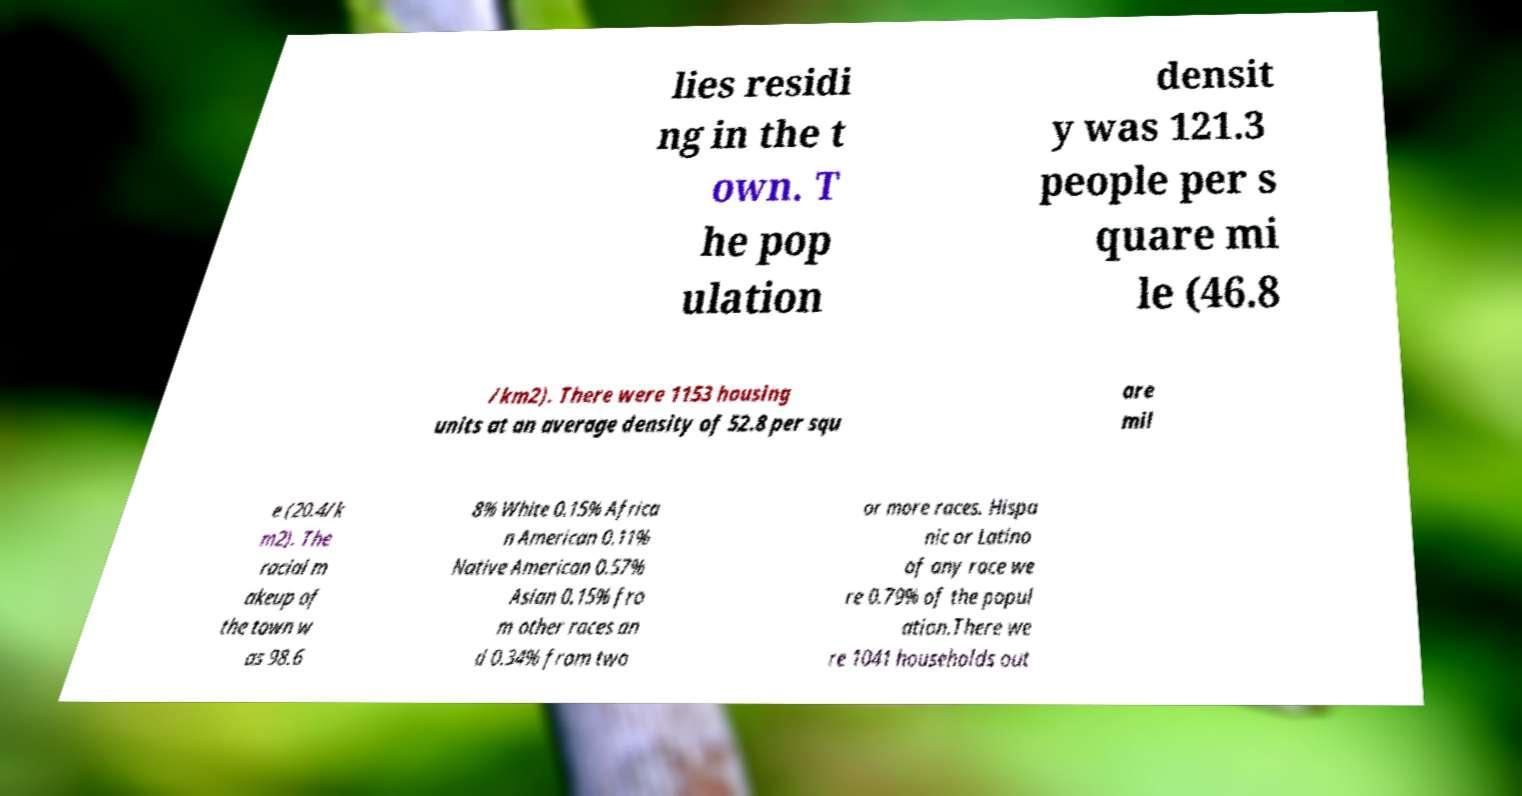I need the written content from this picture converted into text. Can you do that? lies residi ng in the t own. T he pop ulation densit y was 121.3 people per s quare mi le (46.8 /km2). There were 1153 housing units at an average density of 52.8 per squ are mil e (20.4/k m2). The racial m akeup of the town w as 98.6 8% White 0.15% Africa n American 0.11% Native American 0.57% Asian 0.15% fro m other races an d 0.34% from two or more races. Hispa nic or Latino of any race we re 0.79% of the popul ation.There we re 1041 households out 